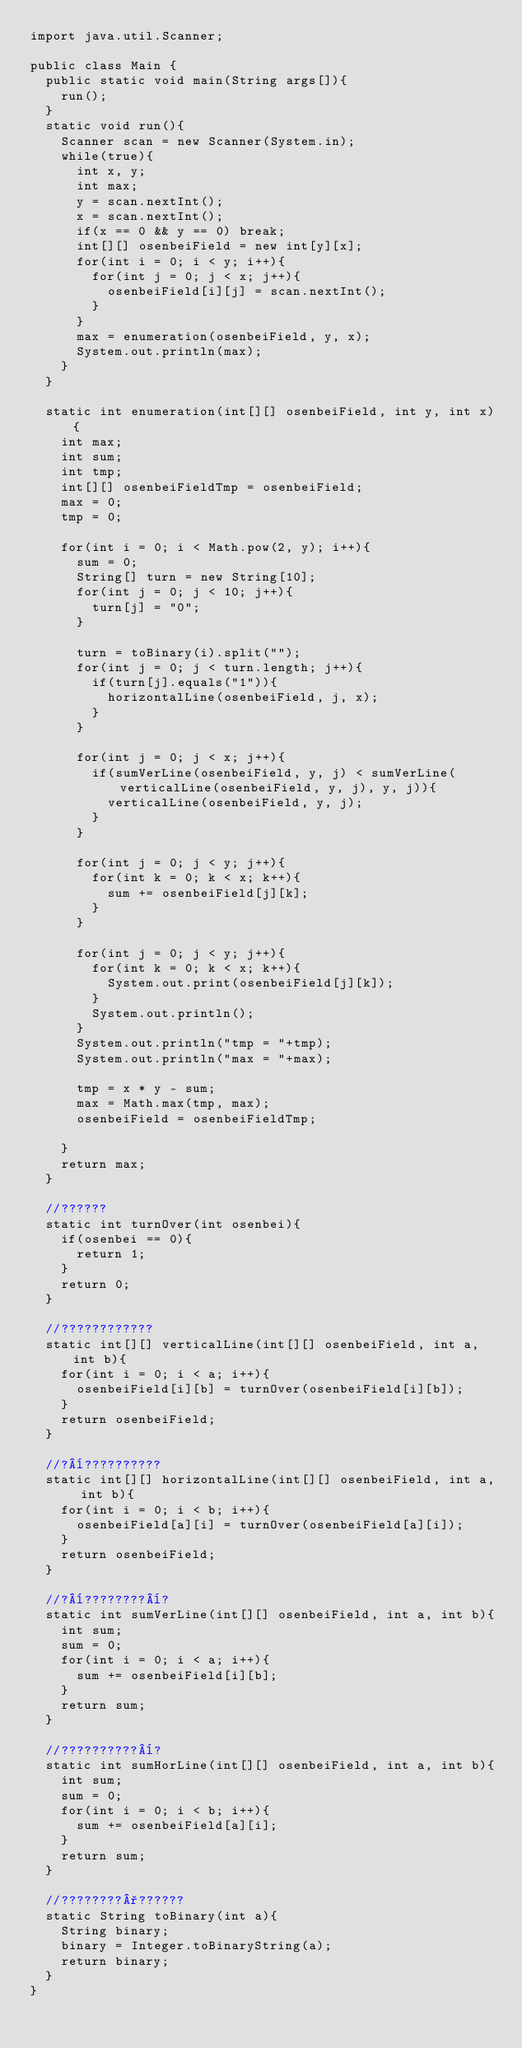Convert code to text. <code><loc_0><loc_0><loc_500><loc_500><_Java_>import java.util.Scanner;

public class Main {
	public static void main(String args[]){
		run();
	}
	static void run(){
		Scanner scan = new Scanner(System.in);
		while(true){
			int x, y;
			int max;
			y = scan.nextInt();
			x = scan.nextInt();
			if(x == 0 && y == 0) break;
			int[][] osenbeiField = new int[y][x];
			for(int i = 0; i < y; i++){
				for(int j = 0; j < x; j++){
					osenbeiField[i][j] = scan.nextInt();
				}
			}
			max = enumeration(osenbeiField, y, x);
			System.out.println(max);
		}
	}
	
	static int enumeration(int[][] osenbeiField, int y, int x){
		int max;
		int sum;
		int tmp;
		int[][] osenbeiFieldTmp = osenbeiField;
		max = 0;
		tmp = 0;
		
		for(int i = 0; i < Math.pow(2, y); i++){
			sum = 0;
			String[] turn = new String[10];
			for(int j = 0; j < 10; j++){
				turn[j] = "0";
			}
			
			turn = toBinary(i).split("");
			for(int j = 0; j < turn.length; j++){
				if(turn[j].equals("1")){
					horizontalLine(osenbeiField, j, x);
				}
			}

			for(int j = 0; j < x; j++){
				if(sumVerLine(osenbeiField, y, j) < sumVerLine(verticalLine(osenbeiField, y, j), y, j)){
					verticalLine(osenbeiField, y, j);
				}
			}
			
			for(int j = 0; j < y; j++){
				for(int k = 0; k < x; k++){
					sum += osenbeiField[j][k];
				}
			}
			
			for(int j = 0; j < y; j++){
				for(int k = 0; k < x; k++){
					System.out.print(osenbeiField[j][k]);
				}
				System.out.println();
			}
			System.out.println("tmp = "+tmp);
			System.out.println("max = "+max);
			
			tmp = x * y - sum;
			max = Math.max(tmp, max);
			osenbeiField = osenbeiFieldTmp;
			
		}
		return max;
	}
	
	//??????
	static int turnOver(int osenbei){
		if(osenbei == 0){
			return 1;
		}
		return 0;
	}
	
	//????????????
	static int[][] verticalLine(int[][] osenbeiField, int a, int b){
		for(int i = 0; i < a; i++){
			osenbeiField[i][b] = turnOver(osenbeiField[i][b]);
		}
		return osenbeiField;
	}
	
	//?¨??????????
	static int[][] horizontalLine(int[][] osenbeiField, int a, int b){
		for(int i = 0; i < b; i++){
			osenbeiField[a][i] = turnOver(osenbeiField[a][i]);
		}
		return osenbeiField;
	}
	
	//?¨????????¨?
	static int sumVerLine(int[][] osenbeiField, int a, int b){
		int sum;
		sum = 0;
		for(int i = 0; i < a; i++){
			sum += osenbeiField[i][b];
		}
		return sum;
	}
	
	//??????????¨?
	static int sumHorLine(int[][] osenbeiField, int a, int b){
		int sum;
		sum = 0;
		for(int i = 0; i < b; i++){
			sum += osenbeiField[a][i];
		}
		return sum;
	}
	
	//????????°??????
	static String toBinary(int a){
		String binary;
		binary = Integer.toBinaryString(a);
		return binary;
	}
}</code> 